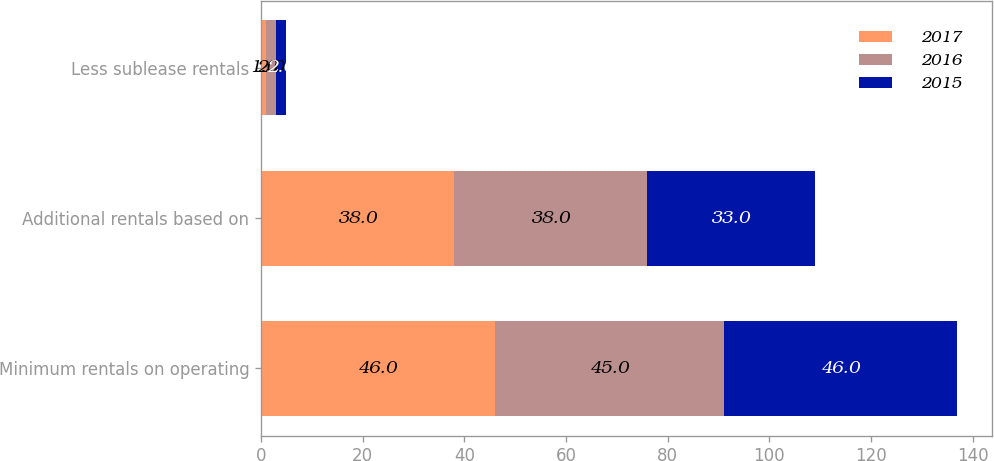Convert chart to OTSL. <chart><loc_0><loc_0><loc_500><loc_500><stacked_bar_chart><ecel><fcel>Minimum rentals on operating<fcel>Additional rentals based on<fcel>Less sublease rentals<nl><fcel>2017<fcel>46<fcel>38<fcel>1<nl><fcel>2016<fcel>45<fcel>38<fcel>2<nl><fcel>2015<fcel>46<fcel>33<fcel>2<nl></chart> 